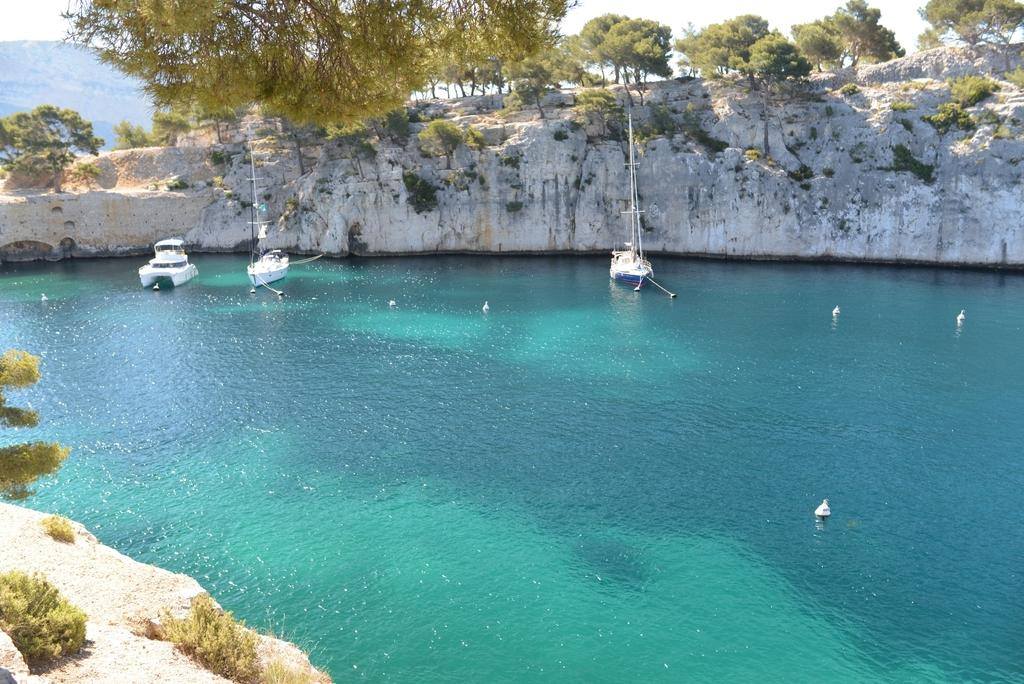What is the main subject of the image? The main subject of the image is boats on water. What other elements can be seen in the image? There are rocks, trees, plants, mountains, and the sky visible in the image. What type of writing can be seen on the rocks in the image? There is no writing visible on the rocks in the image. How many balls are present in the image? There are no balls present in the image. 